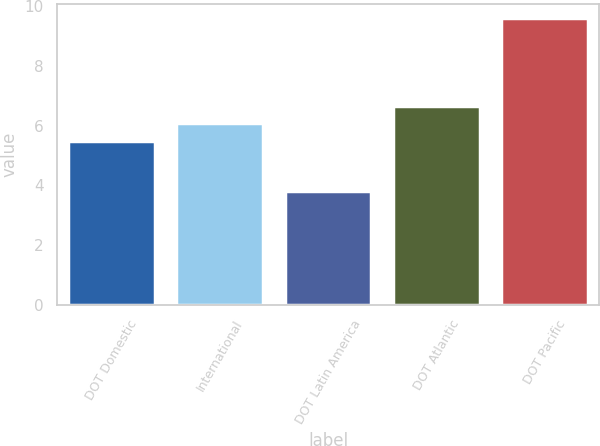Convert chart. <chart><loc_0><loc_0><loc_500><loc_500><bar_chart><fcel>DOT Domestic<fcel>International<fcel>DOT Latin America<fcel>DOT Atlantic<fcel>DOT Pacific<nl><fcel>5.5<fcel>6.08<fcel>3.8<fcel>6.66<fcel>9.6<nl></chart> 